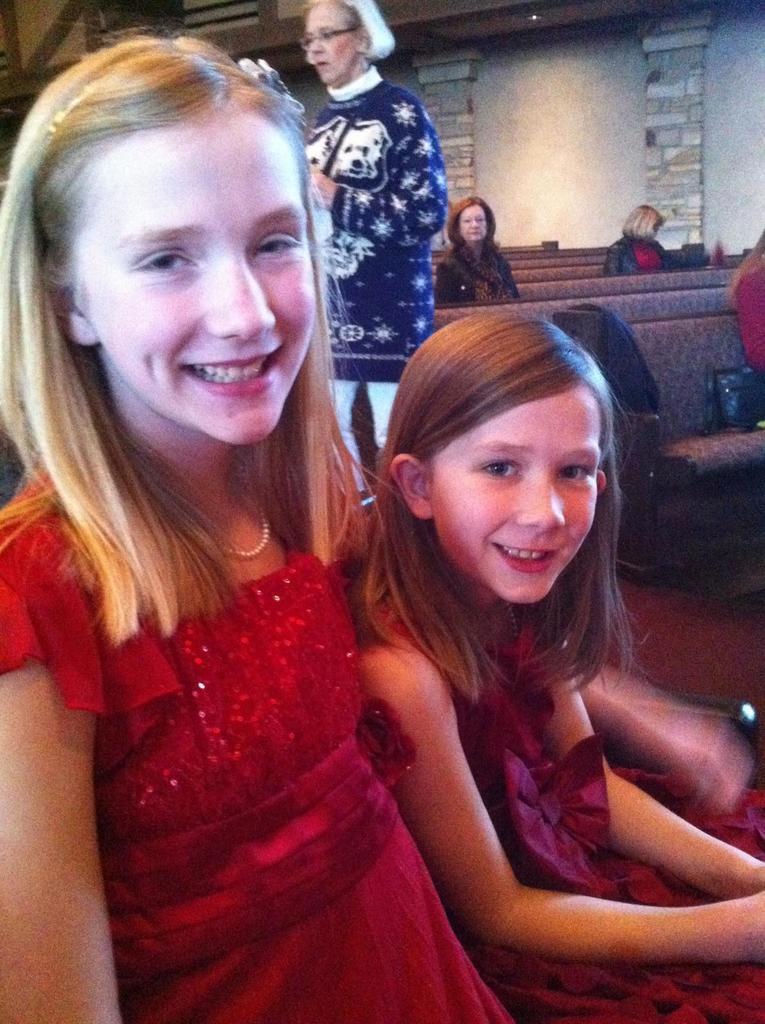Describe this image in one or two sentences. In this picture we can see two girls smiling and at the back of them we can see some people sitting on chairs and a woman standing and in the background we can see the wall. 